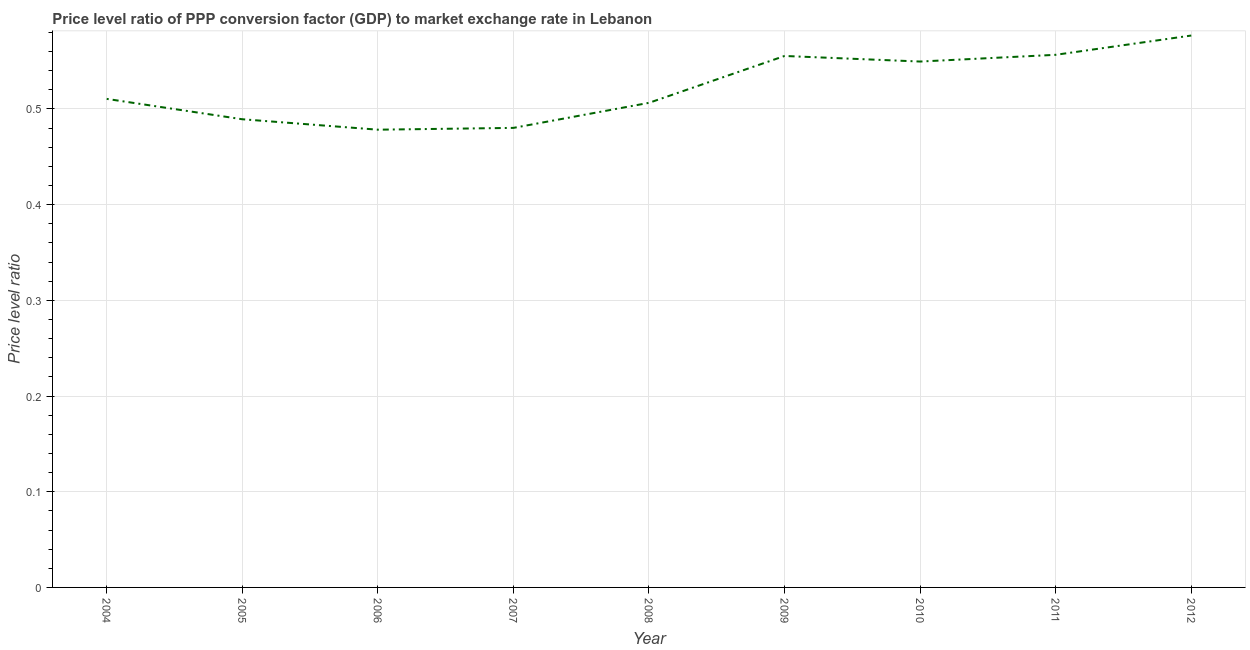What is the price level ratio in 2010?
Provide a short and direct response. 0.55. Across all years, what is the maximum price level ratio?
Offer a very short reply. 0.58. Across all years, what is the minimum price level ratio?
Keep it short and to the point. 0.48. In which year was the price level ratio maximum?
Keep it short and to the point. 2012. What is the sum of the price level ratio?
Offer a terse response. 4.7. What is the difference between the price level ratio in 2005 and 2012?
Offer a terse response. -0.09. What is the average price level ratio per year?
Make the answer very short. 0.52. What is the median price level ratio?
Offer a very short reply. 0.51. In how many years, is the price level ratio greater than 0.08 ?
Provide a succinct answer. 9. Do a majority of the years between 2006 and 2008 (inclusive) have price level ratio greater than 0.5 ?
Make the answer very short. No. What is the ratio of the price level ratio in 2005 to that in 2011?
Ensure brevity in your answer.  0.88. Is the price level ratio in 2008 less than that in 2010?
Keep it short and to the point. Yes. What is the difference between the highest and the second highest price level ratio?
Make the answer very short. 0.02. Is the sum of the price level ratio in 2007 and 2010 greater than the maximum price level ratio across all years?
Provide a succinct answer. Yes. What is the difference between the highest and the lowest price level ratio?
Offer a very short reply. 0.1. In how many years, is the price level ratio greater than the average price level ratio taken over all years?
Your answer should be very brief. 4. How many lines are there?
Your response must be concise. 1. How many years are there in the graph?
Give a very brief answer. 9. Does the graph contain any zero values?
Keep it short and to the point. No. Does the graph contain grids?
Your answer should be very brief. Yes. What is the title of the graph?
Give a very brief answer. Price level ratio of PPP conversion factor (GDP) to market exchange rate in Lebanon. What is the label or title of the X-axis?
Provide a short and direct response. Year. What is the label or title of the Y-axis?
Provide a succinct answer. Price level ratio. What is the Price level ratio of 2004?
Provide a succinct answer. 0.51. What is the Price level ratio of 2005?
Offer a terse response. 0.49. What is the Price level ratio in 2006?
Ensure brevity in your answer.  0.48. What is the Price level ratio of 2007?
Provide a succinct answer. 0.48. What is the Price level ratio in 2008?
Your answer should be very brief. 0.51. What is the Price level ratio of 2009?
Provide a short and direct response. 0.56. What is the Price level ratio in 2010?
Give a very brief answer. 0.55. What is the Price level ratio in 2011?
Your response must be concise. 0.56. What is the Price level ratio of 2012?
Your response must be concise. 0.58. What is the difference between the Price level ratio in 2004 and 2005?
Your answer should be very brief. 0.02. What is the difference between the Price level ratio in 2004 and 2006?
Give a very brief answer. 0.03. What is the difference between the Price level ratio in 2004 and 2007?
Your response must be concise. 0.03. What is the difference between the Price level ratio in 2004 and 2008?
Ensure brevity in your answer.  0. What is the difference between the Price level ratio in 2004 and 2009?
Make the answer very short. -0.04. What is the difference between the Price level ratio in 2004 and 2010?
Keep it short and to the point. -0.04. What is the difference between the Price level ratio in 2004 and 2011?
Offer a terse response. -0.05. What is the difference between the Price level ratio in 2004 and 2012?
Offer a terse response. -0.07. What is the difference between the Price level ratio in 2005 and 2006?
Give a very brief answer. 0.01. What is the difference between the Price level ratio in 2005 and 2007?
Provide a short and direct response. 0.01. What is the difference between the Price level ratio in 2005 and 2008?
Offer a terse response. -0.02. What is the difference between the Price level ratio in 2005 and 2009?
Your answer should be compact. -0.07. What is the difference between the Price level ratio in 2005 and 2010?
Keep it short and to the point. -0.06. What is the difference between the Price level ratio in 2005 and 2011?
Your answer should be very brief. -0.07. What is the difference between the Price level ratio in 2005 and 2012?
Your answer should be compact. -0.09. What is the difference between the Price level ratio in 2006 and 2007?
Offer a terse response. -0. What is the difference between the Price level ratio in 2006 and 2008?
Keep it short and to the point. -0.03. What is the difference between the Price level ratio in 2006 and 2009?
Keep it short and to the point. -0.08. What is the difference between the Price level ratio in 2006 and 2010?
Give a very brief answer. -0.07. What is the difference between the Price level ratio in 2006 and 2011?
Offer a very short reply. -0.08. What is the difference between the Price level ratio in 2006 and 2012?
Make the answer very short. -0.1. What is the difference between the Price level ratio in 2007 and 2008?
Provide a short and direct response. -0.03. What is the difference between the Price level ratio in 2007 and 2009?
Ensure brevity in your answer.  -0.08. What is the difference between the Price level ratio in 2007 and 2010?
Give a very brief answer. -0.07. What is the difference between the Price level ratio in 2007 and 2011?
Offer a very short reply. -0.08. What is the difference between the Price level ratio in 2007 and 2012?
Your answer should be very brief. -0.1. What is the difference between the Price level ratio in 2008 and 2009?
Provide a succinct answer. -0.05. What is the difference between the Price level ratio in 2008 and 2010?
Ensure brevity in your answer.  -0.04. What is the difference between the Price level ratio in 2008 and 2011?
Ensure brevity in your answer.  -0.05. What is the difference between the Price level ratio in 2008 and 2012?
Keep it short and to the point. -0.07. What is the difference between the Price level ratio in 2009 and 2010?
Make the answer very short. 0.01. What is the difference between the Price level ratio in 2009 and 2011?
Offer a terse response. -0. What is the difference between the Price level ratio in 2009 and 2012?
Provide a short and direct response. -0.02. What is the difference between the Price level ratio in 2010 and 2011?
Keep it short and to the point. -0.01. What is the difference between the Price level ratio in 2010 and 2012?
Offer a very short reply. -0.03. What is the difference between the Price level ratio in 2011 and 2012?
Make the answer very short. -0.02. What is the ratio of the Price level ratio in 2004 to that in 2005?
Offer a terse response. 1.04. What is the ratio of the Price level ratio in 2004 to that in 2006?
Your answer should be compact. 1.07. What is the ratio of the Price level ratio in 2004 to that in 2007?
Provide a succinct answer. 1.06. What is the ratio of the Price level ratio in 2004 to that in 2008?
Your response must be concise. 1.01. What is the ratio of the Price level ratio in 2004 to that in 2009?
Give a very brief answer. 0.92. What is the ratio of the Price level ratio in 2004 to that in 2010?
Your response must be concise. 0.93. What is the ratio of the Price level ratio in 2004 to that in 2011?
Provide a succinct answer. 0.92. What is the ratio of the Price level ratio in 2004 to that in 2012?
Your answer should be compact. 0.89. What is the ratio of the Price level ratio in 2005 to that in 2006?
Offer a terse response. 1.02. What is the ratio of the Price level ratio in 2005 to that in 2007?
Give a very brief answer. 1.02. What is the ratio of the Price level ratio in 2005 to that in 2009?
Offer a very short reply. 0.88. What is the ratio of the Price level ratio in 2005 to that in 2010?
Your answer should be very brief. 0.89. What is the ratio of the Price level ratio in 2005 to that in 2011?
Offer a very short reply. 0.88. What is the ratio of the Price level ratio in 2005 to that in 2012?
Provide a short and direct response. 0.85. What is the ratio of the Price level ratio in 2006 to that in 2008?
Your response must be concise. 0.94. What is the ratio of the Price level ratio in 2006 to that in 2009?
Your response must be concise. 0.86. What is the ratio of the Price level ratio in 2006 to that in 2010?
Your answer should be compact. 0.87. What is the ratio of the Price level ratio in 2006 to that in 2011?
Provide a short and direct response. 0.86. What is the ratio of the Price level ratio in 2006 to that in 2012?
Offer a very short reply. 0.83. What is the ratio of the Price level ratio in 2007 to that in 2008?
Your answer should be compact. 0.95. What is the ratio of the Price level ratio in 2007 to that in 2009?
Offer a very short reply. 0.86. What is the ratio of the Price level ratio in 2007 to that in 2010?
Offer a very short reply. 0.87. What is the ratio of the Price level ratio in 2007 to that in 2011?
Offer a very short reply. 0.86. What is the ratio of the Price level ratio in 2007 to that in 2012?
Give a very brief answer. 0.83. What is the ratio of the Price level ratio in 2008 to that in 2009?
Provide a short and direct response. 0.91. What is the ratio of the Price level ratio in 2008 to that in 2010?
Your response must be concise. 0.92. What is the ratio of the Price level ratio in 2008 to that in 2011?
Make the answer very short. 0.91. What is the ratio of the Price level ratio in 2008 to that in 2012?
Provide a short and direct response. 0.88. What is the ratio of the Price level ratio in 2009 to that in 2010?
Ensure brevity in your answer.  1.01. What is the ratio of the Price level ratio in 2009 to that in 2012?
Provide a short and direct response. 0.96. What is the ratio of the Price level ratio in 2010 to that in 2011?
Your answer should be very brief. 0.99. What is the ratio of the Price level ratio in 2010 to that in 2012?
Provide a succinct answer. 0.95. 